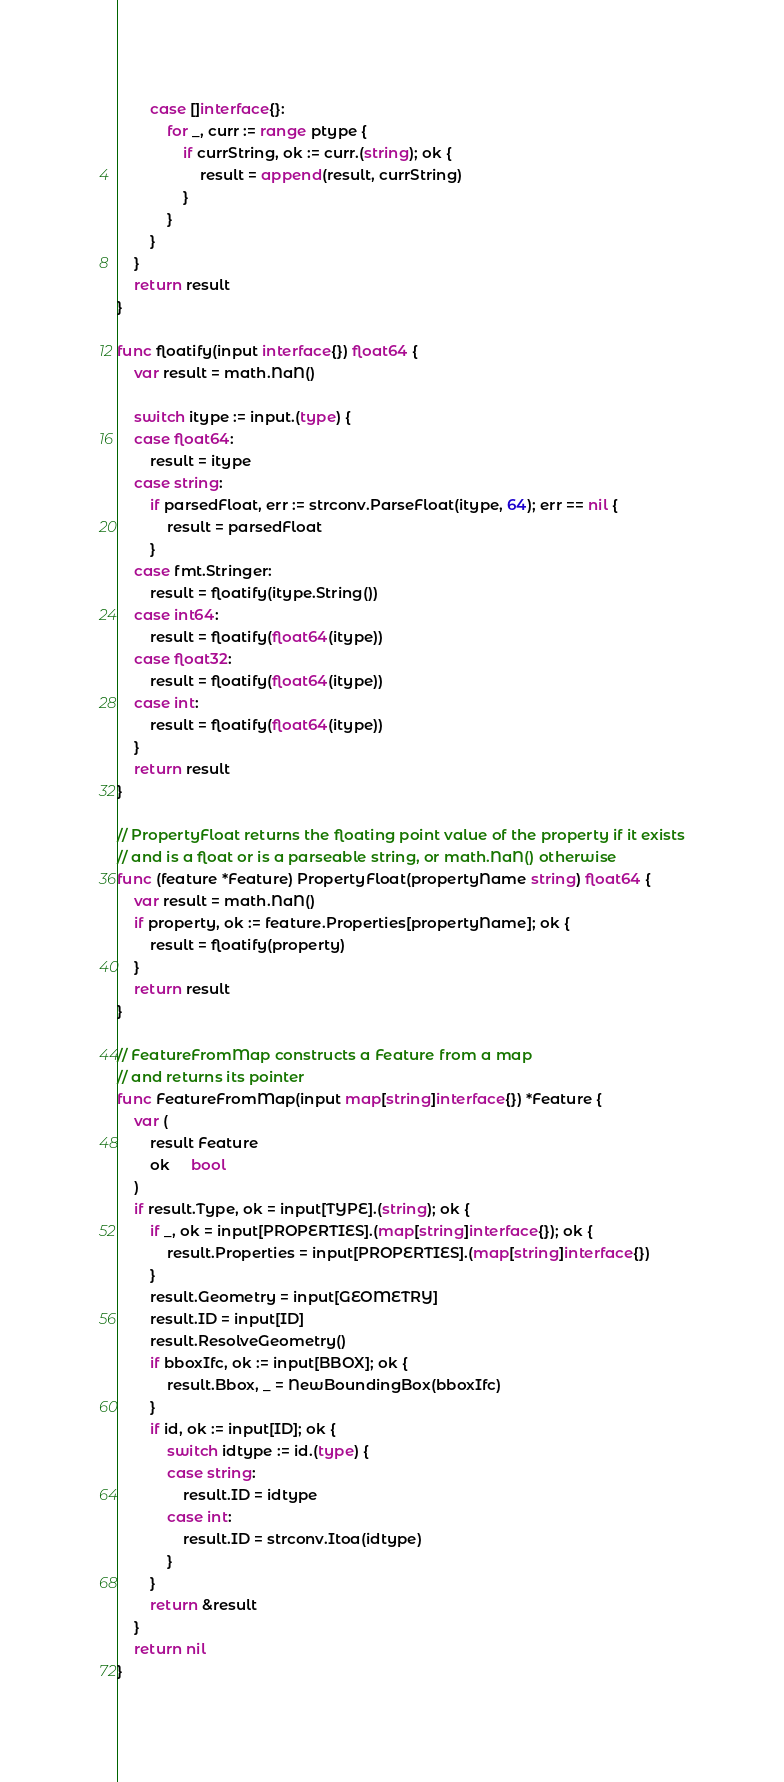Convert code to text. <code><loc_0><loc_0><loc_500><loc_500><_Go_>		case []interface{}:
			for _, curr := range ptype {
				if currString, ok := curr.(string); ok {
					result = append(result, currString)
				}
			}
		}
	}
	return result
}

func floatify(input interface{}) float64 {
	var result = math.NaN()

	switch itype := input.(type) {
	case float64:
		result = itype
	case string:
		if parsedFloat, err := strconv.ParseFloat(itype, 64); err == nil {
			result = parsedFloat
		}
	case fmt.Stringer:
		result = floatify(itype.String())
	case int64:
		result = floatify(float64(itype))
	case float32:
		result = floatify(float64(itype))
	case int:
		result = floatify(float64(itype))
	}
	return result
}

// PropertyFloat returns the floating point value of the property if it exists
// and is a float or is a parseable string, or math.NaN() otherwise
func (feature *Feature) PropertyFloat(propertyName string) float64 {
	var result = math.NaN()
	if property, ok := feature.Properties[propertyName]; ok {
		result = floatify(property)
	}
	return result
}

// FeatureFromMap constructs a Feature from a map
// and returns its pointer
func FeatureFromMap(input map[string]interface{}) *Feature {
	var (
		result Feature
		ok     bool
	)
	if result.Type, ok = input[TYPE].(string); ok {
		if _, ok = input[PROPERTIES].(map[string]interface{}); ok {
			result.Properties = input[PROPERTIES].(map[string]interface{})
		}
		result.Geometry = input[GEOMETRY]
		result.ID = input[ID]
		result.ResolveGeometry()
		if bboxIfc, ok := input[BBOX]; ok {
			result.Bbox, _ = NewBoundingBox(bboxIfc)
		}
		if id, ok := input[ID]; ok {
			switch idtype := id.(type) {
			case string:
				result.ID = idtype
			case int:
				result.ID = strconv.Itoa(idtype)
			}
		}
		return &result
	}
	return nil
}
</code> 